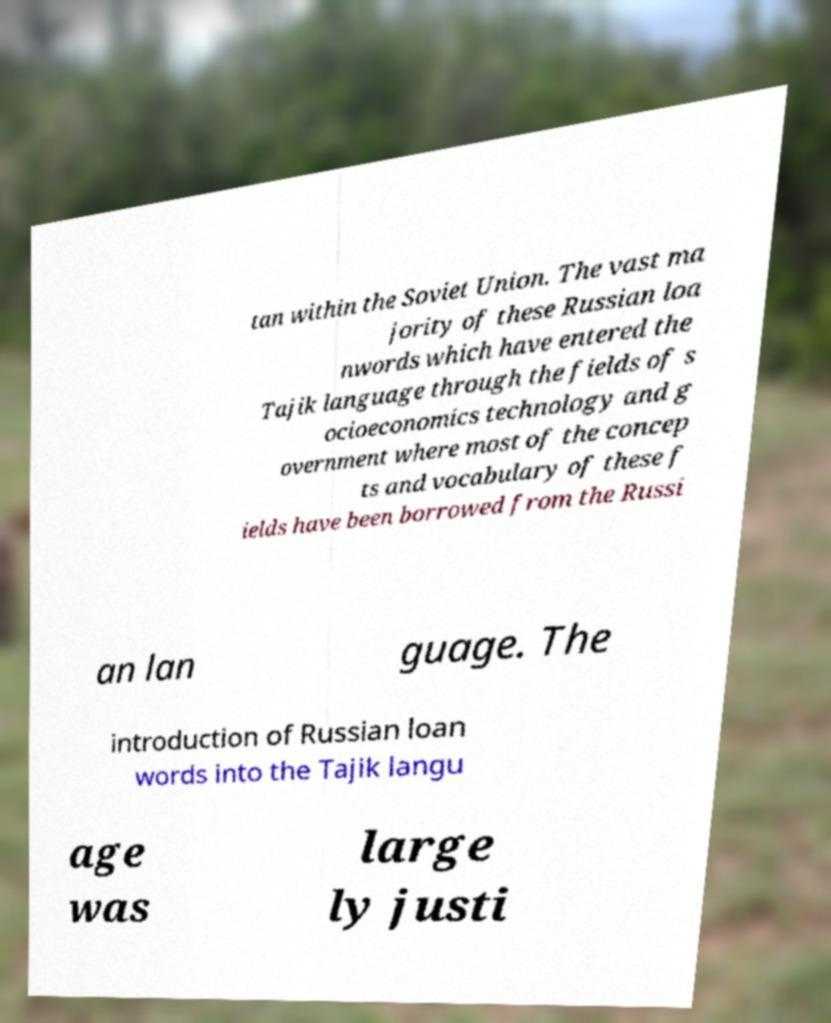There's text embedded in this image that I need extracted. Can you transcribe it verbatim? tan within the Soviet Union. The vast ma jority of these Russian loa nwords which have entered the Tajik language through the fields of s ocioeconomics technology and g overnment where most of the concep ts and vocabulary of these f ields have been borrowed from the Russi an lan guage. The introduction of Russian loan words into the Tajik langu age was large ly justi 